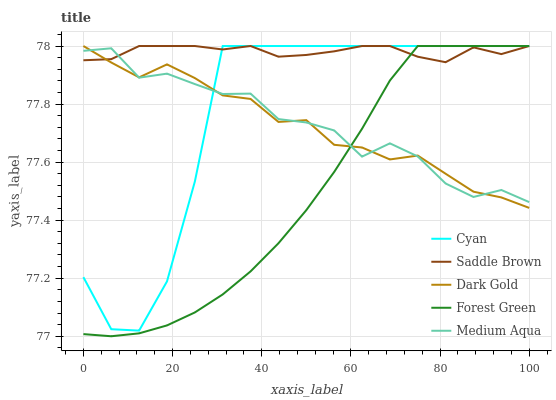Does Forest Green have the minimum area under the curve?
Answer yes or no. Yes. Does Saddle Brown have the maximum area under the curve?
Answer yes or no. Yes. Does Medium Aqua have the minimum area under the curve?
Answer yes or no. No. Does Medium Aqua have the maximum area under the curve?
Answer yes or no. No. Is Forest Green the smoothest?
Answer yes or no. Yes. Is Cyan the roughest?
Answer yes or no. Yes. Is Medium Aqua the smoothest?
Answer yes or no. No. Is Medium Aqua the roughest?
Answer yes or no. No. Does Forest Green have the lowest value?
Answer yes or no. Yes. Does Medium Aqua have the lowest value?
Answer yes or no. No. Does Dark Gold have the highest value?
Answer yes or no. Yes. Does Medium Aqua have the highest value?
Answer yes or no. No. Does Saddle Brown intersect Forest Green?
Answer yes or no. Yes. Is Saddle Brown less than Forest Green?
Answer yes or no. No. Is Saddle Brown greater than Forest Green?
Answer yes or no. No. 